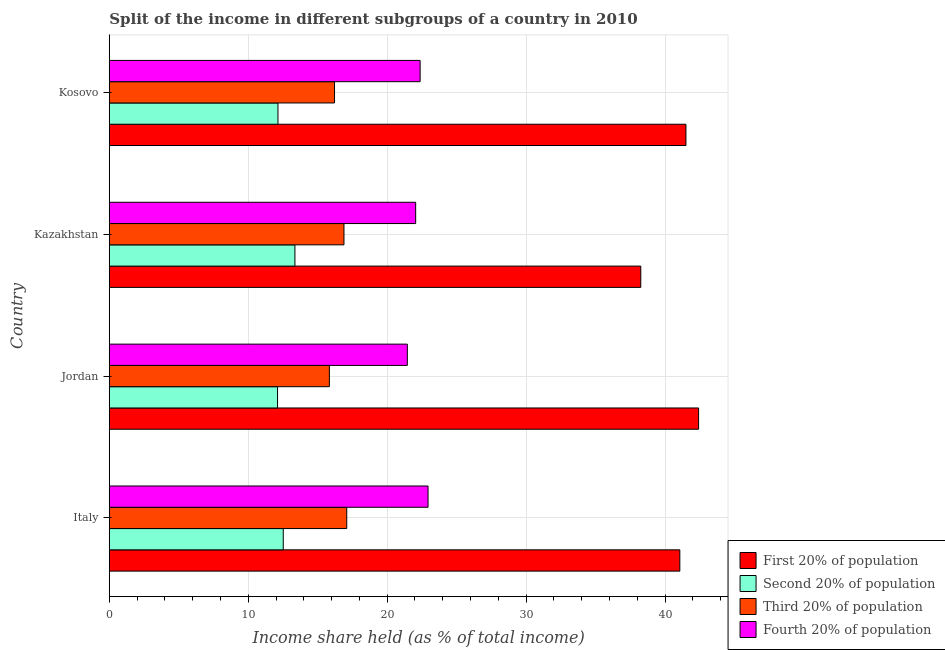How many different coloured bars are there?
Keep it short and to the point. 4. How many groups of bars are there?
Your answer should be very brief. 4. Are the number of bars on each tick of the Y-axis equal?
Provide a succinct answer. Yes. How many bars are there on the 3rd tick from the top?
Provide a short and direct response. 4. What is the label of the 3rd group of bars from the top?
Offer a terse response. Jordan. What is the share of the income held by second 20% of the population in Italy?
Keep it short and to the point. 12.52. Across all countries, what is the maximum share of the income held by second 20% of the population?
Give a very brief answer. 13.36. Across all countries, what is the minimum share of the income held by first 20% of the population?
Your answer should be compact. 38.25. In which country was the share of the income held by third 20% of the population maximum?
Provide a succinct answer. Italy. In which country was the share of the income held by first 20% of the population minimum?
Your response must be concise. Kazakhstan. What is the total share of the income held by second 20% of the population in the graph?
Ensure brevity in your answer.  50.13. What is the difference between the share of the income held by second 20% of the population in Jordan and that in Kosovo?
Your answer should be compact. -0.03. What is the difference between the share of the income held by fourth 20% of the population in Kazakhstan and the share of the income held by first 20% of the population in Italy?
Your answer should be compact. -19.01. What is the average share of the income held by fourth 20% of the population per country?
Keep it short and to the point. 22.2. What is the difference between the share of the income held by second 20% of the population and share of the income held by first 20% of the population in Kosovo?
Your response must be concise. -29.36. In how many countries, is the share of the income held by first 20% of the population greater than 10 %?
Your answer should be very brief. 4. What is the ratio of the share of the income held by fourth 20% of the population in Jordan to that in Kazakhstan?
Keep it short and to the point. 0.97. Is the difference between the share of the income held by second 20% of the population in Jordan and Kosovo greater than the difference between the share of the income held by first 20% of the population in Jordan and Kosovo?
Provide a succinct answer. No. What is the difference between the highest and the second highest share of the income held by second 20% of the population?
Provide a short and direct response. 0.84. What is the difference between the highest and the lowest share of the income held by first 20% of the population?
Ensure brevity in your answer.  4.16. In how many countries, is the share of the income held by second 20% of the population greater than the average share of the income held by second 20% of the population taken over all countries?
Give a very brief answer. 1. Is the sum of the share of the income held by second 20% of the population in Jordan and Kazakhstan greater than the maximum share of the income held by third 20% of the population across all countries?
Provide a short and direct response. Yes. Is it the case that in every country, the sum of the share of the income held by fourth 20% of the population and share of the income held by first 20% of the population is greater than the sum of share of the income held by third 20% of the population and share of the income held by second 20% of the population?
Offer a terse response. No. What does the 1st bar from the top in Kazakhstan represents?
Provide a succinct answer. Fourth 20% of population. What does the 3rd bar from the bottom in Kazakhstan represents?
Your answer should be compact. Third 20% of population. Is it the case that in every country, the sum of the share of the income held by first 20% of the population and share of the income held by second 20% of the population is greater than the share of the income held by third 20% of the population?
Provide a short and direct response. Yes. Are all the bars in the graph horizontal?
Your response must be concise. Yes. Are the values on the major ticks of X-axis written in scientific E-notation?
Offer a terse response. No. Does the graph contain any zero values?
Keep it short and to the point. No. Does the graph contain grids?
Offer a very short reply. Yes. What is the title of the graph?
Your response must be concise. Split of the income in different subgroups of a country in 2010. Does "Manufacturing" appear as one of the legend labels in the graph?
Offer a terse response. No. What is the label or title of the X-axis?
Offer a terse response. Income share held (as % of total income). What is the label or title of the Y-axis?
Give a very brief answer. Country. What is the Income share held (as % of total income) of First 20% of population in Italy?
Offer a very short reply. 41.06. What is the Income share held (as % of total income) of Second 20% of population in Italy?
Your response must be concise. 12.52. What is the Income share held (as % of total income) of Third 20% of population in Italy?
Keep it short and to the point. 17.09. What is the Income share held (as % of total income) of Fourth 20% of population in Italy?
Your answer should be compact. 22.94. What is the Income share held (as % of total income) of First 20% of population in Jordan?
Give a very brief answer. 42.41. What is the Income share held (as % of total income) of Second 20% of population in Jordan?
Offer a very short reply. 12.11. What is the Income share held (as % of total income) in Third 20% of population in Jordan?
Give a very brief answer. 15.84. What is the Income share held (as % of total income) of Fourth 20% of population in Jordan?
Provide a short and direct response. 21.45. What is the Income share held (as % of total income) of First 20% of population in Kazakhstan?
Make the answer very short. 38.25. What is the Income share held (as % of total income) of Second 20% of population in Kazakhstan?
Make the answer very short. 13.36. What is the Income share held (as % of total income) of Third 20% of population in Kazakhstan?
Offer a very short reply. 16.89. What is the Income share held (as % of total income) of Fourth 20% of population in Kazakhstan?
Provide a succinct answer. 22.05. What is the Income share held (as % of total income) of First 20% of population in Kosovo?
Keep it short and to the point. 41.5. What is the Income share held (as % of total income) of Second 20% of population in Kosovo?
Your answer should be very brief. 12.14. What is the Income share held (as % of total income) of Third 20% of population in Kosovo?
Provide a succinct answer. 16.21. What is the Income share held (as % of total income) of Fourth 20% of population in Kosovo?
Your response must be concise. 22.37. Across all countries, what is the maximum Income share held (as % of total income) of First 20% of population?
Keep it short and to the point. 42.41. Across all countries, what is the maximum Income share held (as % of total income) of Second 20% of population?
Provide a short and direct response. 13.36. Across all countries, what is the maximum Income share held (as % of total income) of Third 20% of population?
Your answer should be compact. 17.09. Across all countries, what is the maximum Income share held (as % of total income) of Fourth 20% of population?
Offer a terse response. 22.94. Across all countries, what is the minimum Income share held (as % of total income) of First 20% of population?
Keep it short and to the point. 38.25. Across all countries, what is the minimum Income share held (as % of total income) in Second 20% of population?
Your answer should be compact. 12.11. Across all countries, what is the minimum Income share held (as % of total income) of Third 20% of population?
Give a very brief answer. 15.84. Across all countries, what is the minimum Income share held (as % of total income) in Fourth 20% of population?
Ensure brevity in your answer.  21.45. What is the total Income share held (as % of total income) in First 20% of population in the graph?
Ensure brevity in your answer.  163.22. What is the total Income share held (as % of total income) of Second 20% of population in the graph?
Provide a succinct answer. 50.13. What is the total Income share held (as % of total income) in Third 20% of population in the graph?
Give a very brief answer. 66.03. What is the total Income share held (as % of total income) in Fourth 20% of population in the graph?
Make the answer very short. 88.81. What is the difference between the Income share held (as % of total income) in First 20% of population in Italy and that in Jordan?
Give a very brief answer. -1.35. What is the difference between the Income share held (as % of total income) in Second 20% of population in Italy and that in Jordan?
Provide a short and direct response. 0.41. What is the difference between the Income share held (as % of total income) of Third 20% of population in Italy and that in Jordan?
Give a very brief answer. 1.25. What is the difference between the Income share held (as % of total income) of Fourth 20% of population in Italy and that in Jordan?
Make the answer very short. 1.49. What is the difference between the Income share held (as % of total income) in First 20% of population in Italy and that in Kazakhstan?
Provide a succinct answer. 2.81. What is the difference between the Income share held (as % of total income) in Second 20% of population in Italy and that in Kazakhstan?
Your response must be concise. -0.84. What is the difference between the Income share held (as % of total income) of Fourth 20% of population in Italy and that in Kazakhstan?
Offer a very short reply. 0.89. What is the difference between the Income share held (as % of total income) of First 20% of population in Italy and that in Kosovo?
Your answer should be very brief. -0.44. What is the difference between the Income share held (as % of total income) of Second 20% of population in Italy and that in Kosovo?
Your answer should be very brief. 0.38. What is the difference between the Income share held (as % of total income) in Fourth 20% of population in Italy and that in Kosovo?
Provide a succinct answer. 0.57. What is the difference between the Income share held (as % of total income) in First 20% of population in Jordan and that in Kazakhstan?
Offer a terse response. 4.16. What is the difference between the Income share held (as % of total income) of Second 20% of population in Jordan and that in Kazakhstan?
Provide a short and direct response. -1.25. What is the difference between the Income share held (as % of total income) in Third 20% of population in Jordan and that in Kazakhstan?
Provide a short and direct response. -1.05. What is the difference between the Income share held (as % of total income) in First 20% of population in Jordan and that in Kosovo?
Provide a short and direct response. 0.91. What is the difference between the Income share held (as % of total income) of Second 20% of population in Jordan and that in Kosovo?
Offer a terse response. -0.03. What is the difference between the Income share held (as % of total income) in Third 20% of population in Jordan and that in Kosovo?
Provide a short and direct response. -0.37. What is the difference between the Income share held (as % of total income) of Fourth 20% of population in Jordan and that in Kosovo?
Provide a short and direct response. -0.92. What is the difference between the Income share held (as % of total income) of First 20% of population in Kazakhstan and that in Kosovo?
Your answer should be compact. -3.25. What is the difference between the Income share held (as % of total income) in Second 20% of population in Kazakhstan and that in Kosovo?
Provide a succinct answer. 1.22. What is the difference between the Income share held (as % of total income) in Third 20% of population in Kazakhstan and that in Kosovo?
Provide a short and direct response. 0.68. What is the difference between the Income share held (as % of total income) of Fourth 20% of population in Kazakhstan and that in Kosovo?
Your answer should be very brief. -0.32. What is the difference between the Income share held (as % of total income) of First 20% of population in Italy and the Income share held (as % of total income) of Second 20% of population in Jordan?
Offer a terse response. 28.95. What is the difference between the Income share held (as % of total income) in First 20% of population in Italy and the Income share held (as % of total income) in Third 20% of population in Jordan?
Offer a terse response. 25.22. What is the difference between the Income share held (as % of total income) in First 20% of population in Italy and the Income share held (as % of total income) in Fourth 20% of population in Jordan?
Offer a terse response. 19.61. What is the difference between the Income share held (as % of total income) of Second 20% of population in Italy and the Income share held (as % of total income) of Third 20% of population in Jordan?
Provide a succinct answer. -3.32. What is the difference between the Income share held (as % of total income) in Second 20% of population in Italy and the Income share held (as % of total income) in Fourth 20% of population in Jordan?
Give a very brief answer. -8.93. What is the difference between the Income share held (as % of total income) of Third 20% of population in Italy and the Income share held (as % of total income) of Fourth 20% of population in Jordan?
Your answer should be compact. -4.36. What is the difference between the Income share held (as % of total income) of First 20% of population in Italy and the Income share held (as % of total income) of Second 20% of population in Kazakhstan?
Provide a succinct answer. 27.7. What is the difference between the Income share held (as % of total income) in First 20% of population in Italy and the Income share held (as % of total income) in Third 20% of population in Kazakhstan?
Make the answer very short. 24.17. What is the difference between the Income share held (as % of total income) of First 20% of population in Italy and the Income share held (as % of total income) of Fourth 20% of population in Kazakhstan?
Your answer should be compact. 19.01. What is the difference between the Income share held (as % of total income) of Second 20% of population in Italy and the Income share held (as % of total income) of Third 20% of population in Kazakhstan?
Provide a short and direct response. -4.37. What is the difference between the Income share held (as % of total income) in Second 20% of population in Italy and the Income share held (as % of total income) in Fourth 20% of population in Kazakhstan?
Provide a short and direct response. -9.53. What is the difference between the Income share held (as % of total income) of Third 20% of population in Italy and the Income share held (as % of total income) of Fourth 20% of population in Kazakhstan?
Ensure brevity in your answer.  -4.96. What is the difference between the Income share held (as % of total income) in First 20% of population in Italy and the Income share held (as % of total income) in Second 20% of population in Kosovo?
Your answer should be very brief. 28.92. What is the difference between the Income share held (as % of total income) in First 20% of population in Italy and the Income share held (as % of total income) in Third 20% of population in Kosovo?
Provide a short and direct response. 24.85. What is the difference between the Income share held (as % of total income) in First 20% of population in Italy and the Income share held (as % of total income) in Fourth 20% of population in Kosovo?
Your response must be concise. 18.69. What is the difference between the Income share held (as % of total income) of Second 20% of population in Italy and the Income share held (as % of total income) of Third 20% of population in Kosovo?
Your answer should be very brief. -3.69. What is the difference between the Income share held (as % of total income) in Second 20% of population in Italy and the Income share held (as % of total income) in Fourth 20% of population in Kosovo?
Give a very brief answer. -9.85. What is the difference between the Income share held (as % of total income) in Third 20% of population in Italy and the Income share held (as % of total income) in Fourth 20% of population in Kosovo?
Offer a very short reply. -5.28. What is the difference between the Income share held (as % of total income) of First 20% of population in Jordan and the Income share held (as % of total income) of Second 20% of population in Kazakhstan?
Provide a short and direct response. 29.05. What is the difference between the Income share held (as % of total income) of First 20% of population in Jordan and the Income share held (as % of total income) of Third 20% of population in Kazakhstan?
Ensure brevity in your answer.  25.52. What is the difference between the Income share held (as % of total income) of First 20% of population in Jordan and the Income share held (as % of total income) of Fourth 20% of population in Kazakhstan?
Keep it short and to the point. 20.36. What is the difference between the Income share held (as % of total income) of Second 20% of population in Jordan and the Income share held (as % of total income) of Third 20% of population in Kazakhstan?
Offer a terse response. -4.78. What is the difference between the Income share held (as % of total income) in Second 20% of population in Jordan and the Income share held (as % of total income) in Fourth 20% of population in Kazakhstan?
Provide a succinct answer. -9.94. What is the difference between the Income share held (as % of total income) of Third 20% of population in Jordan and the Income share held (as % of total income) of Fourth 20% of population in Kazakhstan?
Your answer should be compact. -6.21. What is the difference between the Income share held (as % of total income) in First 20% of population in Jordan and the Income share held (as % of total income) in Second 20% of population in Kosovo?
Your answer should be very brief. 30.27. What is the difference between the Income share held (as % of total income) in First 20% of population in Jordan and the Income share held (as % of total income) in Third 20% of population in Kosovo?
Provide a succinct answer. 26.2. What is the difference between the Income share held (as % of total income) in First 20% of population in Jordan and the Income share held (as % of total income) in Fourth 20% of population in Kosovo?
Offer a terse response. 20.04. What is the difference between the Income share held (as % of total income) of Second 20% of population in Jordan and the Income share held (as % of total income) of Third 20% of population in Kosovo?
Offer a terse response. -4.1. What is the difference between the Income share held (as % of total income) of Second 20% of population in Jordan and the Income share held (as % of total income) of Fourth 20% of population in Kosovo?
Offer a terse response. -10.26. What is the difference between the Income share held (as % of total income) of Third 20% of population in Jordan and the Income share held (as % of total income) of Fourth 20% of population in Kosovo?
Provide a short and direct response. -6.53. What is the difference between the Income share held (as % of total income) in First 20% of population in Kazakhstan and the Income share held (as % of total income) in Second 20% of population in Kosovo?
Your answer should be very brief. 26.11. What is the difference between the Income share held (as % of total income) in First 20% of population in Kazakhstan and the Income share held (as % of total income) in Third 20% of population in Kosovo?
Offer a very short reply. 22.04. What is the difference between the Income share held (as % of total income) in First 20% of population in Kazakhstan and the Income share held (as % of total income) in Fourth 20% of population in Kosovo?
Make the answer very short. 15.88. What is the difference between the Income share held (as % of total income) in Second 20% of population in Kazakhstan and the Income share held (as % of total income) in Third 20% of population in Kosovo?
Provide a succinct answer. -2.85. What is the difference between the Income share held (as % of total income) in Second 20% of population in Kazakhstan and the Income share held (as % of total income) in Fourth 20% of population in Kosovo?
Your answer should be very brief. -9.01. What is the difference between the Income share held (as % of total income) of Third 20% of population in Kazakhstan and the Income share held (as % of total income) of Fourth 20% of population in Kosovo?
Your answer should be very brief. -5.48. What is the average Income share held (as % of total income) of First 20% of population per country?
Your response must be concise. 40.8. What is the average Income share held (as % of total income) in Second 20% of population per country?
Offer a very short reply. 12.53. What is the average Income share held (as % of total income) in Third 20% of population per country?
Your answer should be compact. 16.51. What is the average Income share held (as % of total income) in Fourth 20% of population per country?
Provide a short and direct response. 22.2. What is the difference between the Income share held (as % of total income) of First 20% of population and Income share held (as % of total income) of Second 20% of population in Italy?
Your answer should be very brief. 28.54. What is the difference between the Income share held (as % of total income) of First 20% of population and Income share held (as % of total income) of Third 20% of population in Italy?
Your answer should be compact. 23.97. What is the difference between the Income share held (as % of total income) of First 20% of population and Income share held (as % of total income) of Fourth 20% of population in Italy?
Your response must be concise. 18.12. What is the difference between the Income share held (as % of total income) in Second 20% of population and Income share held (as % of total income) in Third 20% of population in Italy?
Offer a terse response. -4.57. What is the difference between the Income share held (as % of total income) in Second 20% of population and Income share held (as % of total income) in Fourth 20% of population in Italy?
Provide a succinct answer. -10.42. What is the difference between the Income share held (as % of total income) of Third 20% of population and Income share held (as % of total income) of Fourth 20% of population in Italy?
Keep it short and to the point. -5.85. What is the difference between the Income share held (as % of total income) in First 20% of population and Income share held (as % of total income) in Second 20% of population in Jordan?
Ensure brevity in your answer.  30.3. What is the difference between the Income share held (as % of total income) in First 20% of population and Income share held (as % of total income) in Third 20% of population in Jordan?
Offer a terse response. 26.57. What is the difference between the Income share held (as % of total income) in First 20% of population and Income share held (as % of total income) in Fourth 20% of population in Jordan?
Make the answer very short. 20.96. What is the difference between the Income share held (as % of total income) in Second 20% of population and Income share held (as % of total income) in Third 20% of population in Jordan?
Make the answer very short. -3.73. What is the difference between the Income share held (as % of total income) in Second 20% of population and Income share held (as % of total income) in Fourth 20% of population in Jordan?
Keep it short and to the point. -9.34. What is the difference between the Income share held (as % of total income) in Third 20% of population and Income share held (as % of total income) in Fourth 20% of population in Jordan?
Provide a short and direct response. -5.61. What is the difference between the Income share held (as % of total income) in First 20% of population and Income share held (as % of total income) in Second 20% of population in Kazakhstan?
Give a very brief answer. 24.89. What is the difference between the Income share held (as % of total income) of First 20% of population and Income share held (as % of total income) of Third 20% of population in Kazakhstan?
Ensure brevity in your answer.  21.36. What is the difference between the Income share held (as % of total income) in First 20% of population and Income share held (as % of total income) in Fourth 20% of population in Kazakhstan?
Your answer should be compact. 16.2. What is the difference between the Income share held (as % of total income) of Second 20% of population and Income share held (as % of total income) of Third 20% of population in Kazakhstan?
Your answer should be compact. -3.53. What is the difference between the Income share held (as % of total income) in Second 20% of population and Income share held (as % of total income) in Fourth 20% of population in Kazakhstan?
Give a very brief answer. -8.69. What is the difference between the Income share held (as % of total income) in Third 20% of population and Income share held (as % of total income) in Fourth 20% of population in Kazakhstan?
Provide a short and direct response. -5.16. What is the difference between the Income share held (as % of total income) of First 20% of population and Income share held (as % of total income) of Second 20% of population in Kosovo?
Give a very brief answer. 29.36. What is the difference between the Income share held (as % of total income) of First 20% of population and Income share held (as % of total income) of Third 20% of population in Kosovo?
Ensure brevity in your answer.  25.29. What is the difference between the Income share held (as % of total income) of First 20% of population and Income share held (as % of total income) of Fourth 20% of population in Kosovo?
Provide a short and direct response. 19.13. What is the difference between the Income share held (as % of total income) in Second 20% of population and Income share held (as % of total income) in Third 20% of population in Kosovo?
Give a very brief answer. -4.07. What is the difference between the Income share held (as % of total income) in Second 20% of population and Income share held (as % of total income) in Fourth 20% of population in Kosovo?
Make the answer very short. -10.23. What is the difference between the Income share held (as % of total income) of Third 20% of population and Income share held (as % of total income) of Fourth 20% of population in Kosovo?
Make the answer very short. -6.16. What is the ratio of the Income share held (as % of total income) in First 20% of population in Italy to that in Jordan?
Provide a short and direct response. 0.97. What is the ratio of the Income share held (as % of total income) in Second 20% of population in Italy to that in Jordan?
Keep it short and to the point. 1.03. What is the ratio of the Income share held (as % of total income) in Third 20% of population in Italy to that in Jordan?
Your answer should be compact. 1.08. What is the ratio of the Income share held (as % of total income) in Fourth 20% of population in Italy to that in Jordan?
Give a very brief answer. 1.07. What is the ratio of the Income share held (as % of total income) of First 20% of population in Italy to that in Kazakhstan?
Your answer should be very brief. 1.07. What is the ratio of the Income share held (as % of total income) of Second 20% of population in Italy to that in Kazakhstan?
Keep it short and to the point. 0.94. What is the ratio of the Income share held (as % of total income) of Third 20% of population in Italy to that in Kazakhstan?
Make the answer very short. 1.01. What is the ratio of the Income share held (as % of total income) in Fourth 20% of population in Italy to that in Kazakhstan?
Your response must be concise. 1.04. What is the ratio of the Income share held (as % of total income) in First 20% of population in Italy to that in Kosovo?
Keep it short and to the point. 0.99. What is the ratio of the Income share held (as % of total income) of Second 20% of population in Italy to that in Kosovo?
Your answer should be very brief. 1.03. What is the ratio of the Income share held (as % of total income) in Third 20% of population in Italy to that in Kosovo?
Offer a terse response. 1.05. What is the ratio of the Income share held (as % of total income) in Fourth 20% of population in Italy to that in Kosovo?
Your answer should be very brief. 1.03. What is the ratio of the Income share held (as % of total income) in First 20% of population in Jordan to that in Kazakhstan?
Offer a terse response. 1.11. What is the ratio of the Income share held (as % of total income) in Second 20% of population in Jordan to that in Kazakhstan?
Provide a short and direct response. 0.91. What is the ratio of the Income share held (as % of total income) in Third 20% of population in Jordan to that in Kazakhstan?
Make the answer very short. 0.94. What is the ratio of the Income share held (as % of total income) in Fourth 20% of population in Jordan to that in Kazakhstan?
Your answer should be very brief. 0.97. What is the ratio of the Income share held (as % of total income) of First 20% of population in Jordan to that in Kosovo?
Keep it short and to the point. 1.02. What is the ratio of the Income share held (as % of total income) in Third 20% of population in Jordan to that in Kosovo?
Your response must be concise. 0.98. What is the ratio of the Income share held (as % of total income) in Fourth 20% of population in Jordan to that in Kosovo?
Provide a short and direct response. 0.96. What is the ratio of the Income share held (as % of total income) of First 20% of population in Kazakhstan to that in Kosovo?
Offer a terse response. 0.92. What is the ratio of the Income share held (as % of total income) of Second 20% of population in Kazakhstan to that in Kosovo?
Provide a short and direct response. 1.1. What is the ratio of the Income share held (as % of total income) of Third 20% of population in Kazakhstan to that in Kosovo?
Make the answer very short. 1.04. What is the ratio of the Income share held (as % of total income) of Fourth 20% of population in Kazakhstan to that in Kosovo?
Ensure brevity in your answer.  0.99. What is the difference between the highest and the second highest Income share held (as % of total income) of First 20% of population?
Your answer should be compact. 0.91. What is the difference between the highest and the second highest Income share held (as % of total income) in Second 20% of population?
Provide a short and direct response. 0.84. What is the difference between the highest and the second highest Income share held (as % of total income) of Third 20% of population?
Your answer should be compact. 0.2. What is the difference between the highest and the second highest Income share held (as % of total income) in Fourth 20% of population?
Provide a succinct answer. 0.57. What is the difference between the highest and the lowest Income share held (as % of total income) in First 20% of population?
Your answer should be very brief. 4.16. What is the difference between the highest and the lowest Income share held (as % of total income) of Second 20% of population?
Your response must be concise. 1.25. What is the difference between the highest and the lowest Income share held (as % of total income) in Fourth 20% of population?
Offer a terse response. 1.49. 